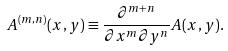<formula> <loc_0><loc_0><loc_500><loc_500>A ^ { ( m , n ) } ( x , y ) \equiv \frac { \partial ^ { m + n } } { \partial x ^ { m } \partial y ^ { n } } A ( x , y ) .</formula> 